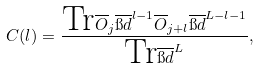<formula> <loc_0><loc_0><loc_500><loc_500>C ( l ) = \frac { \text {Tr} \overline { O } _ { j } \overline { \i d } ^ { l - 1 } \overline { O } _ { j + l } \overline { \i d } ^ { L - l - 1 } } { \text {Tr} \overline { \i d } ^ { L } } ,</formula> 